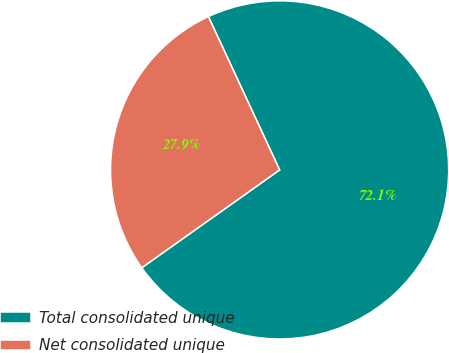Convert chart. <chart><loc_0><loc_0><loc_500><loc_500><pie_chart><fcel>Total consolidated unique<fcel>Net consolidated unique<nl><fcel>72.1%<fcel>27.9%<nl></chart> 